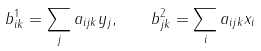<formula> <loc_0><loc_0><loc_500><loc_500>b ^ { 1 } _ { i k } = \sum _ { j } a _ { i j k } y _ { j } , \quad b ^ { 2 } _ { j k } = \sum _ { i } a _ { i j k } x _ { i }</formula> 